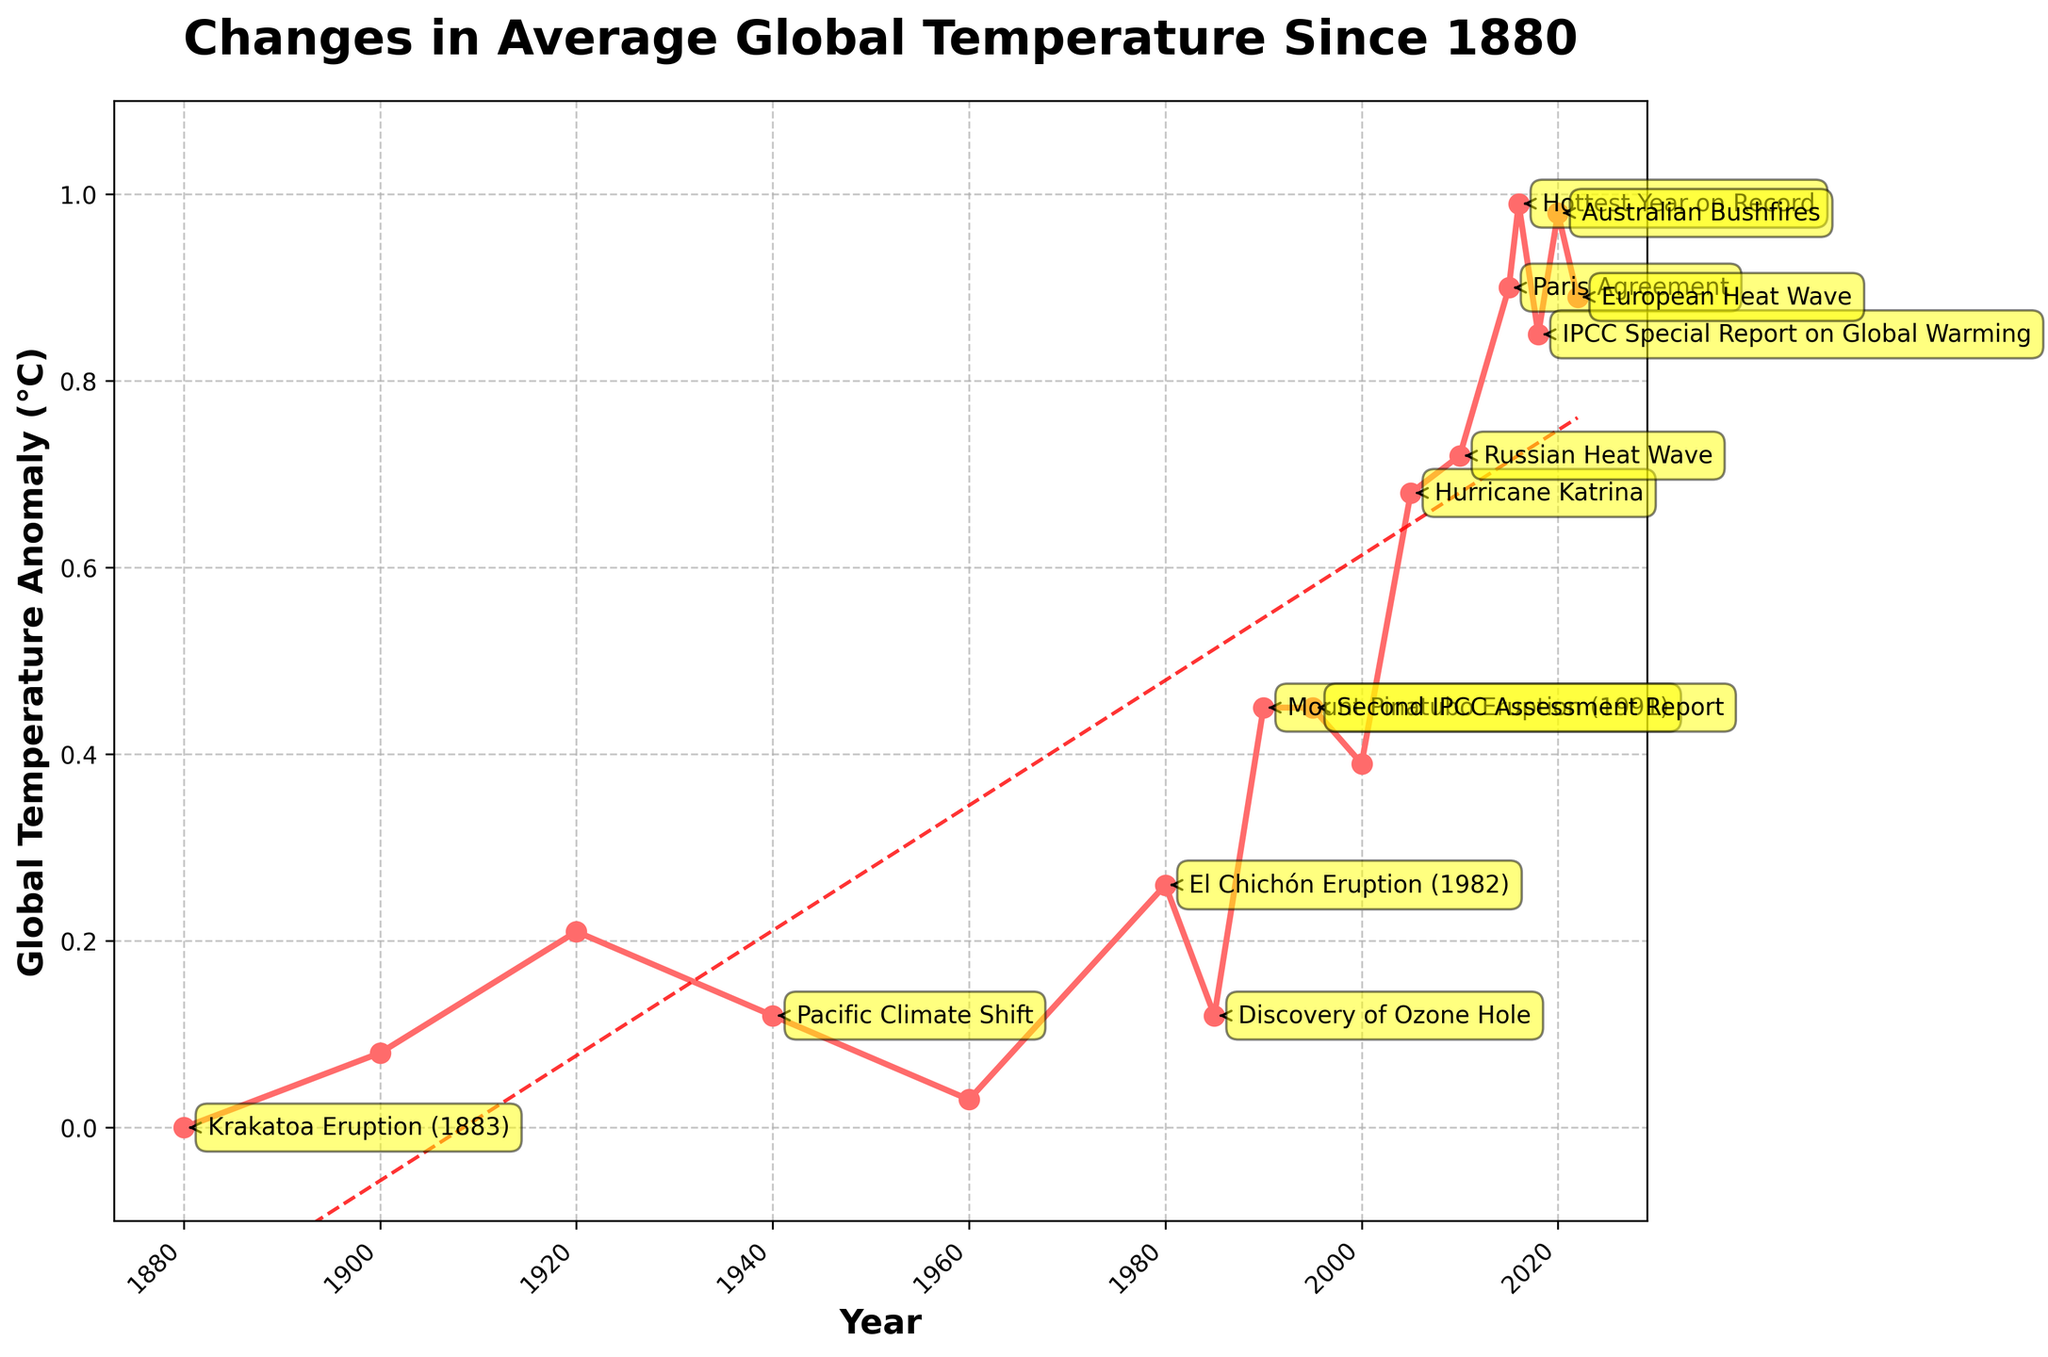What notable climate event coincided with the highest recorded global temperature anomaly? The line chart shows a peak in the global temperature anomaly in 2016 at 0.99°C. The notable climate event highlighted for that year is "Hottest Year on Record."
Answer: Hottest Year on Record How did the global temperature anomaly change from the year Krakatoa erupted (1883) to the year of the El Chichón eruption (1982)? In 1880, the global temperature anomaly was 0.00°C and increased to 0.26°C by 1980, close to the year of El Chichón eruption.
Answer: Increased by 0.26°C Which notable climate event coincided with a temperature anomaly similar to that observed during the Mount Pinatubo eruption (1991)? During the Mount Pinatubo eruption in 1991, the temperature anomaly was around 0.45°C. This is the same temperature anomaly observed in 1995, coinciding with the Second IPCC Assessment Report.
Answer: Second IPCC Assessment Report By examining the trend line, what is the general trend in global temperature anomalies from 1880 to 2022? The line chart displays an upward-sloping trend line, indicating a general increase in global temperature anomalies from 1880 to 2022.
Answer: Increase What is the difference in the global temperature anomaly between the discovery of the ozone hole (1985) and the Australian bushfires (2020)? According to the chart, the global temperature anomaly was 0.12°C in 1985 (Discovery of Ozone Hole) and 0.98°C in 2020 (Australian Bushfires). The difference is calculated as 0.98°C - 0.12°C = 0.86°C.
Answer: 0.86°C How much did the global temperature anomaly increase from 2005 (Hurricane Katrina) to 2016 (Hottest Year on Record)? The global temperature anomaly was 0.68°C in 2005 and 0.99°C in 2016. The increase is 0.99°C - 0.68°C = 0.31°C.
Answer: 0.31°C What was the global temperature anomaly during the Paris Agreement in 2015, and how does it compare to the anomaly in 1900? The global temperature anomaly in 2015 (Paris Agreement) was 0.90°C. In 1900, it was 0.08°C. The difference is 0.90°C - 0.08°C = 0.82°C higher in 2015.
Answer: 0.82°C higher Which year experienced an anomaly close to the one recorded during the Russian heatwave in 2010, and what notable event is associated with that year? During the Russian heatwave in 2010, the anomaly was 0.72°C. The anomaly for 2018 was 0.85°C and the notable event was the IPCC Special Report on Global Warming. Frequencies is 0.13
Answer: European Heat Wave What key climate event is annotated at the point where the anomaly is 0.68°C? The anomaly was 0.68°C in 2005, and the notable climate event annotated at that point is Hurricane Katrina.
Answer: Hurricane Katrina 